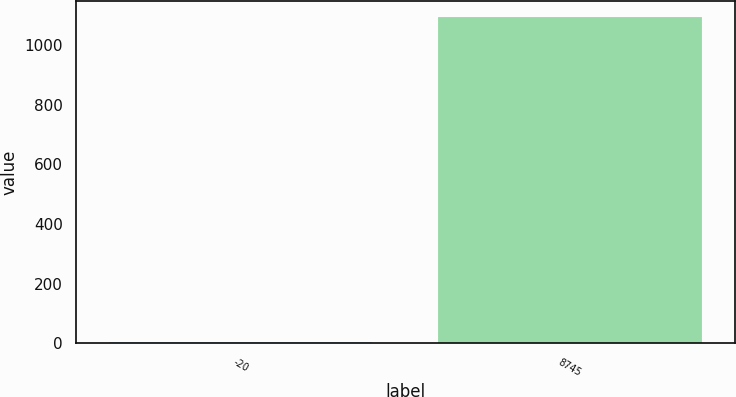Convert chart. <chart><loc_0><loc_0><loc_500><loc_500><bar_chart><fcel>-20<fcel>8745<nl><fcel>3.35<fcel>1093.1<nl></chart> 